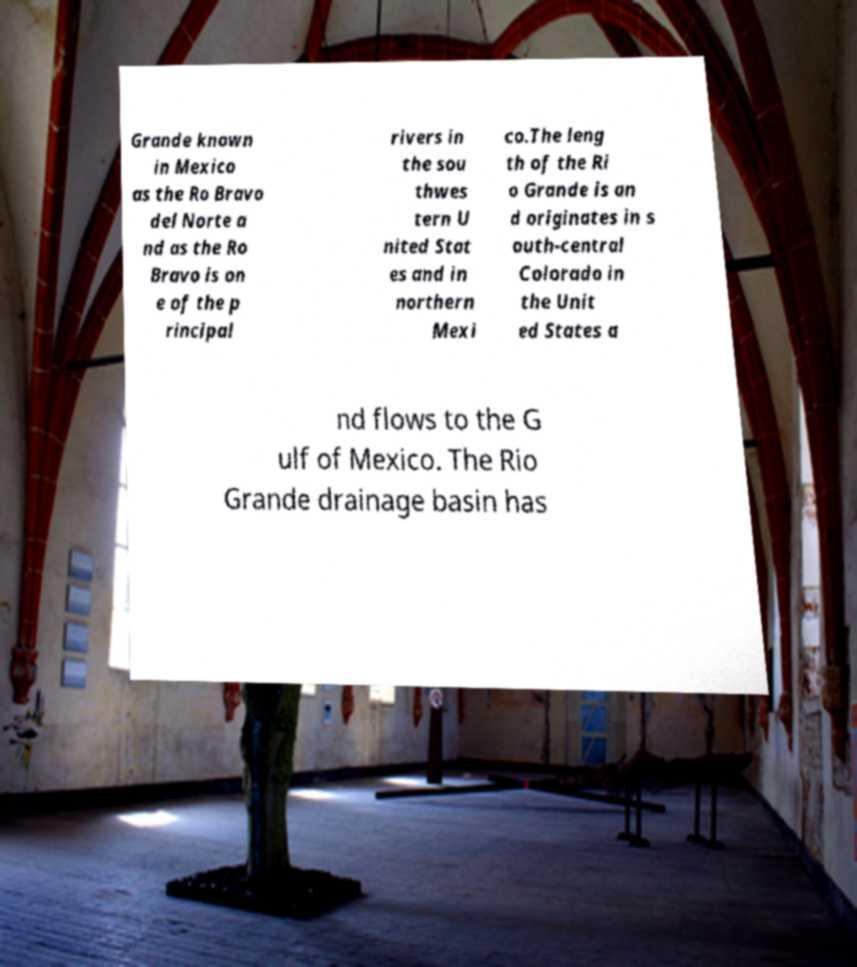Please identify and transcribe the text found in this image. Grande known in Mexico as the Ro Bravo del Norte a nd as the Ro Bravo is on e of the p rincipal rivers in the sou thwes tern U nited Stat es and in northern Mexi co.The leng th of the Ri o Grande is an d originates in s outh-central Colorado in the Unit ed States a nd flows to the G ulf of Mexico. The Rio Grande drainage basin has 